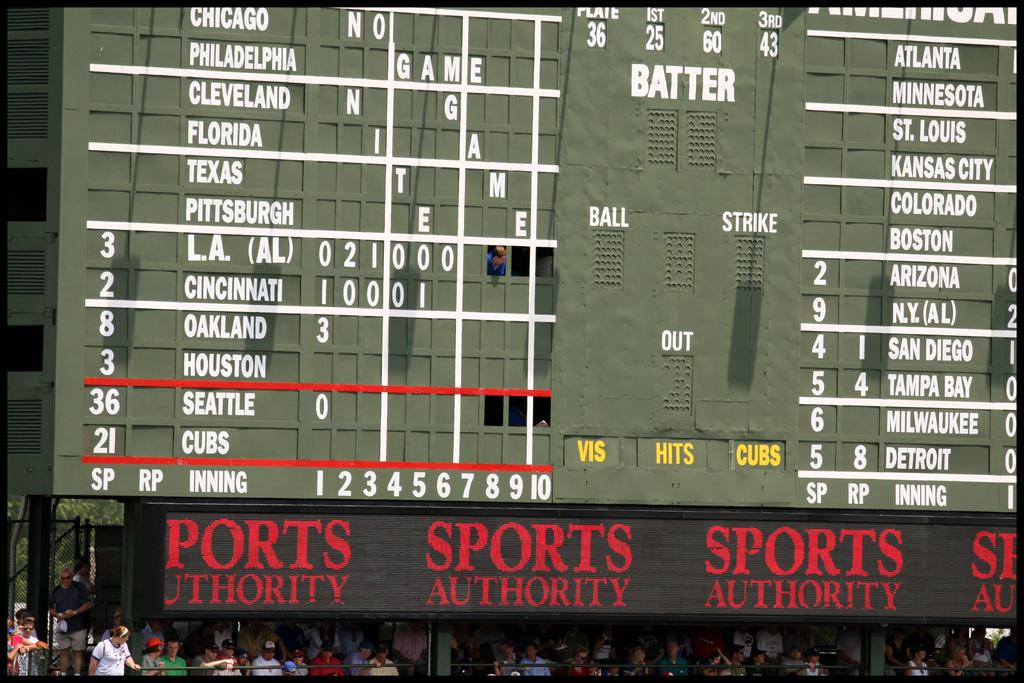<image>
Give a short and clear explanation of the subsequent image. A score board at an event sponsored by the Sports Authority. 